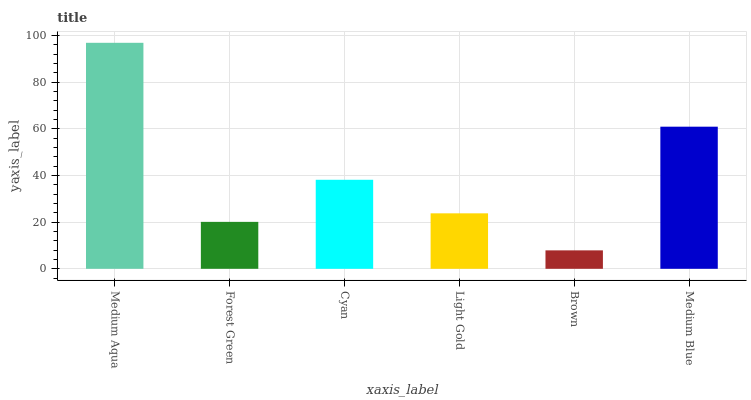Is Brown the minimum?
Answer yes or no. Yes. Is Medium Aqua the maximum?
Answer yes or no. Yes. Is Forest Green the minimum?
Answer yes or no. No. Is Forest Green the maximum?
Answer yes or no. No. Is Medium Aqua greater than Forest Green?
Answer yes or no. Yes. Is Forest Green less than Medium Aqua?
Answer yes or no. Yes. Is Forest Green greater than Medium Aqua?
Answer yes or no. No. Is Medium Aqua less than Forest Green?
Answer yes or no. No. Is Cyan the high median?
Answer yes or no. Yes. Is Light Gold the low median?
Answer yes or no. Yes. Is Medium Aqua the high median?
Answer yes or no. No. Is Brown the low median?
Answer yes or no. No. 